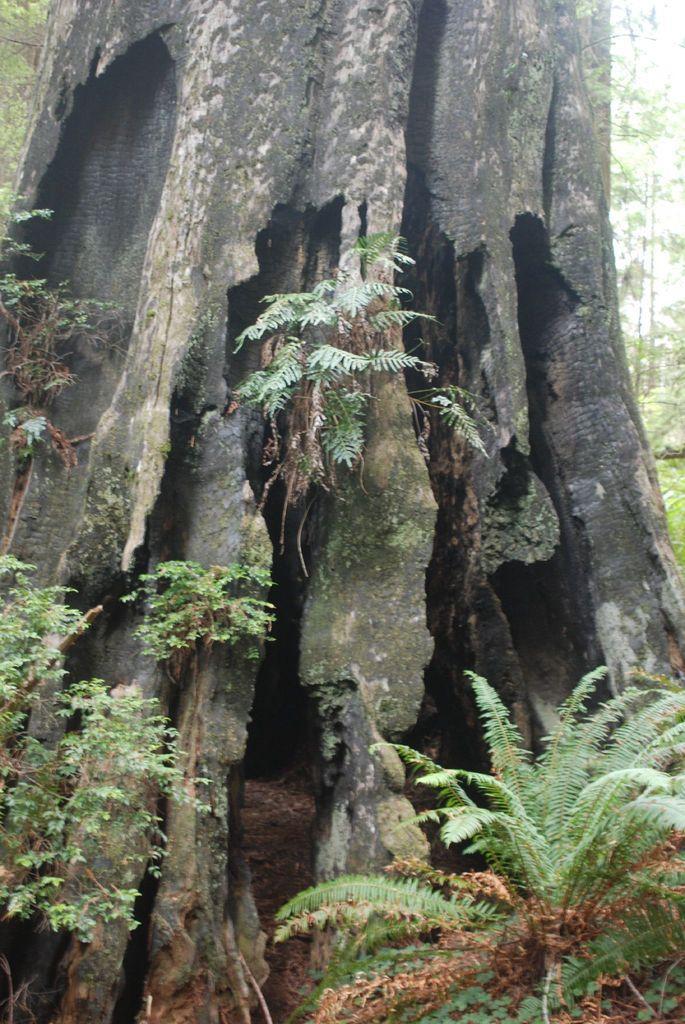Could you give a brief overview of what you see in this image? In this image I can see the trees. In the background I can see the sky. 